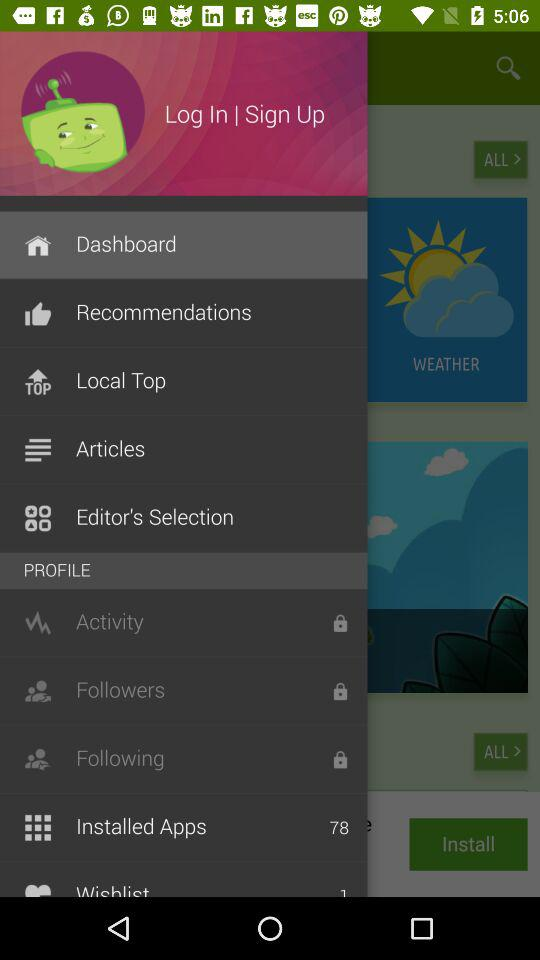What is the number of installed applications? The number of installed applications is 78. 